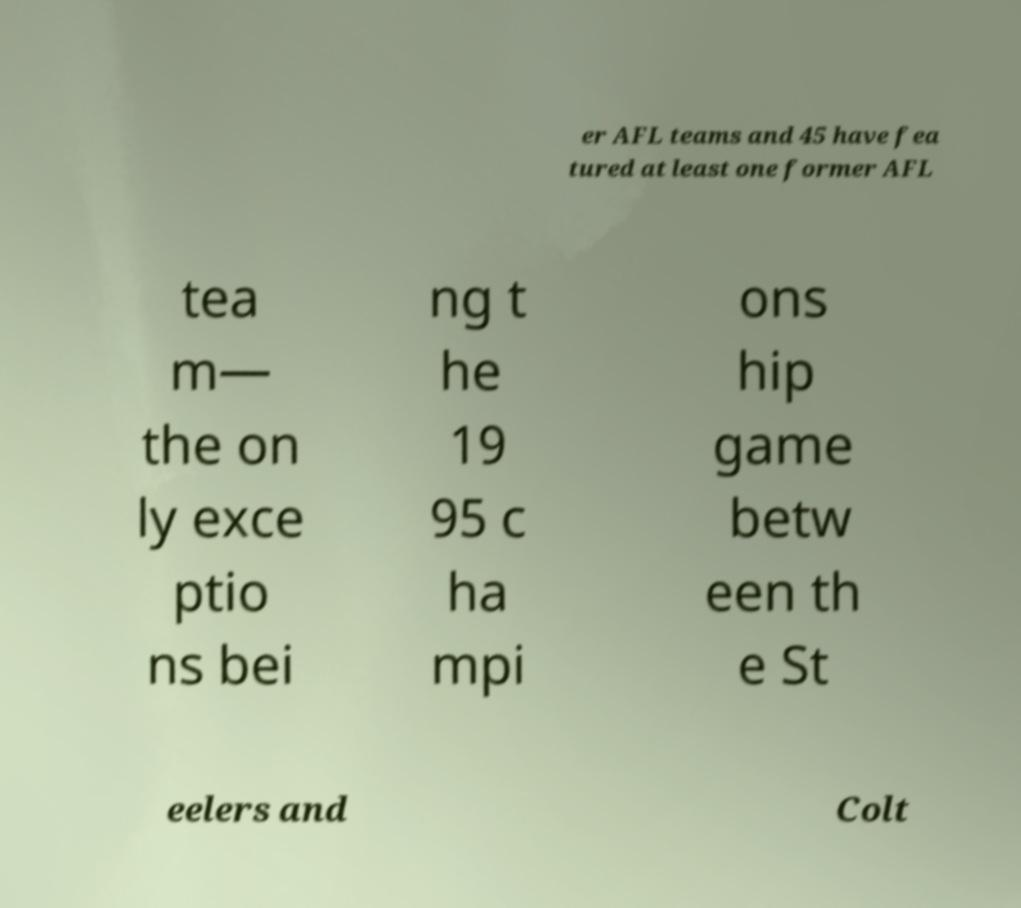Please identify and transcribe the text found in this image. er AFL teams and 45 have fea tured at least one former AFL tea m— the on ly exce ptio ns bei ng t he 19 95 c ha mpi ons hip game betw een th e St eelers and Colt 